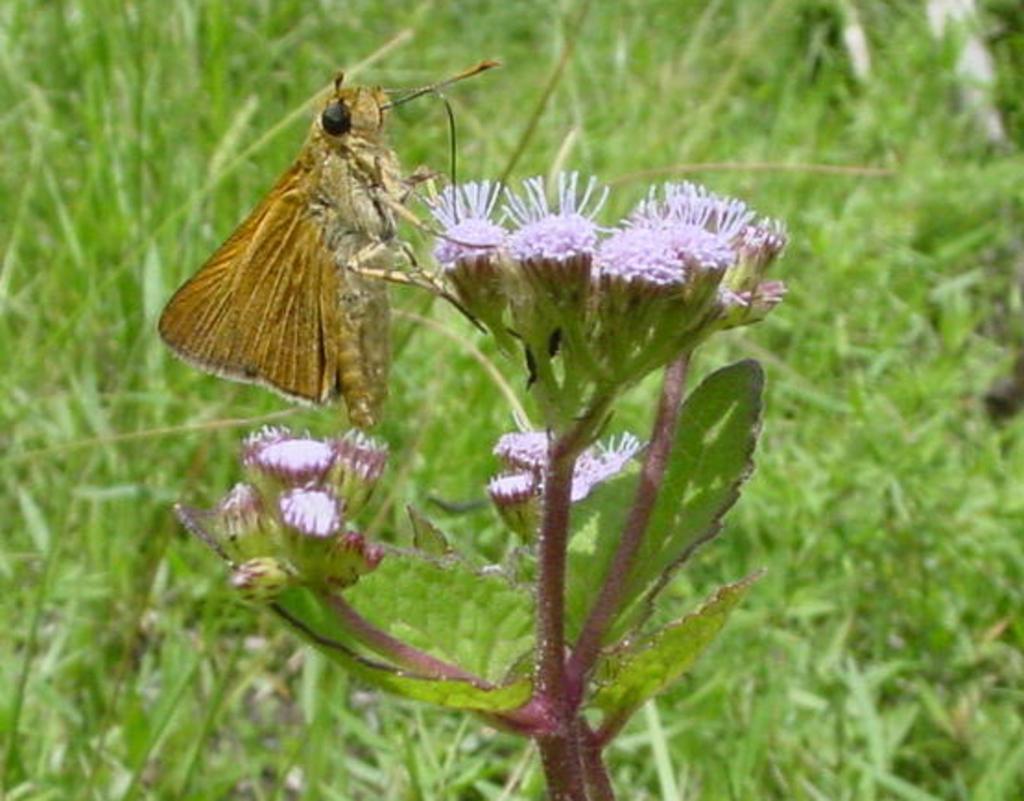How would you summarize this image in a sentence or two? In this image we can see a fly on the flower. In the background there is grass. 